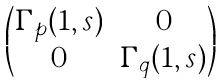Convert formula to latex. <formula><loc_0><loc_0><loc_500><loc_500>\begin{pmatrix} \Gamma _ { p } ( 1 , s ) & 0 \\ 0 & \Gamma _ { q } ( 1 , s ) \end{pmatrix}</formula> 